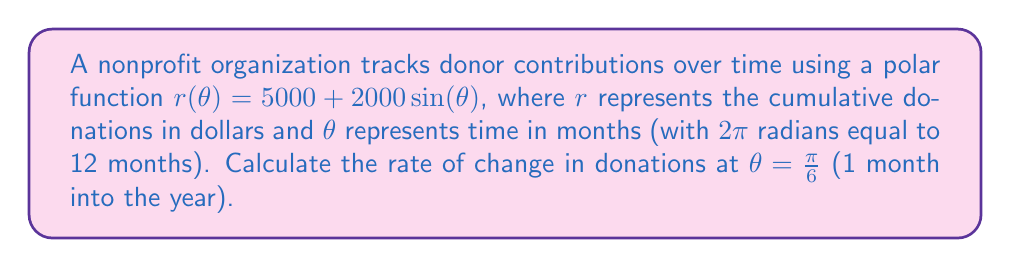What is the answer to this math problem? To find the rate of change in donations at a specific point, we need to calculate the derivative of the polar function with respect to $\theta$ and evaluate it at the given point.

1) The general formula for the rate of change in a polar function is:

   $$\frac{dr}{dt} = \frac{dr}{d\theta} \cdot \frac{d\theta}{dt}$$

2) We need to find $\frac{dr}{d\theta}$:
   
   $$\frac{dr}{d\theta} = 2000\cos(\theta)$$

3) We also need $\frac{d\theta}{dt}$. Since $2\pi$ radians = 12 months, we can say:

   $$\frac{d\theta}{dt} = \frac{2\pi}{12} = \frac{\pi}{6} \text{ radians/month}$$

4) Now we can substitute these into our rate of change formula:

   $$\frac{dr}{dt} = 2000\cos(\theta) \cdot \frac{\pi}{6}$$

5) Evaluate this at $\theta = \frac{\pi}{6}$:

   $$\frac{dr}{dt} = 2000\cos(\frac{\pi}{6}) \cdot \frac{\pi}{6}$$

6) Simplify:
   
   $$\frac{dr}{dt} = 2000 \cdot \frac{\sqrt{3}}{2} \cdot \frac{\pi}{6} = \frac{1000\sqrt{3}\pi}{6} \approx 907.57$$

This result represents the rate of change in dollars per month.
Answer: The rate of change in donations at $\theta = \frac{\pi}{6}$ is $\frac{1000\sqrt{3}\pi}{6}$ dollars per month, or approximately $907.57 dollars per month. 